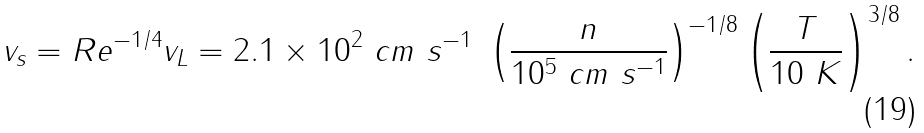Convert formula to latex. <formula><loc_0><loc_0><loc_500><loc_500>v _ { s } = R e ^ { - 1 / 4 } v _ { L } = 2 . 1 \times 1 0 ^ { 2 } \ c m \ s ^ { - 1 } \ \left ( \frac { n } { 1 0 ^ { 5 } \ c m \ s ^ { - 1 } } \right ) ^ { - 1 / 8 } \left ( \frac { T } { 1 0 \ K } \right ) ^ { 3 / 8 } .</formula> 